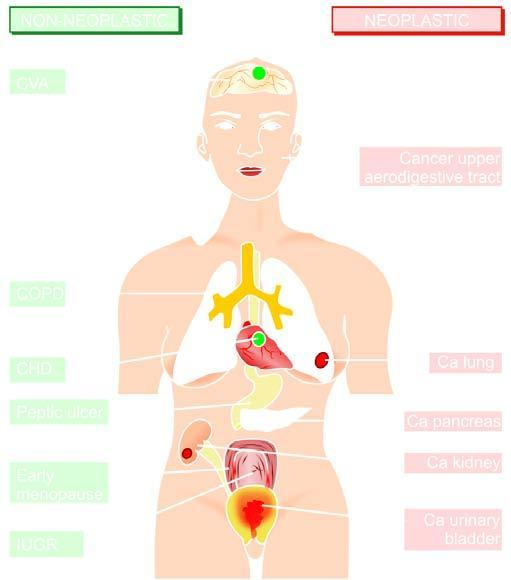what does left side indicate?
Answer the question using a single word or phrase. Non-neoplastic diseases associated with smoking 